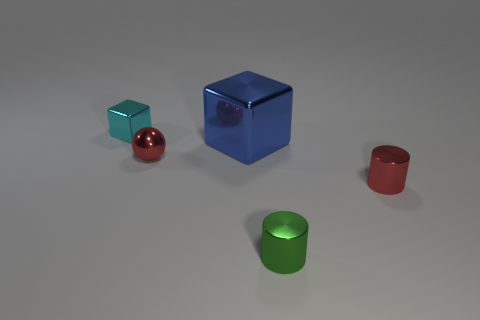There is a red shiny thing that is in front of the red metallic ball; what size is it?
Your answer should be very brief. Small. What shape is the big blue thing?
Make the answer very short. Cube. Does the shiny block behind the blue metal object have the same size as the red ball that is to the left of the red cylinder?
Keep it short and to the point. Yes. How big is the red metallic thing that is to the left of the small cylinder behind the metallic object in front of the tiny red cylinder?
Ensure brevity in your answer.  Small. What shape is the red object that is left of the metallic block in front of the shiny thing behind the big blue metal cube?
Keep it short and to the point. Sphere. What is the shape of the small thing that is in front of the tiny red cylinder?
Provide a succinct answer. Cylinder. Do the small red sphere and the small cylinder in front of the red cylinder have the same material?
Provide a short and direct response. Yes. How many other things are there of the same shape as the blue shiny object?
Your answer should be very brief. 1. Is the color of the small block the same as the shiny thing that is on the right side of the tiny green cylinder?
Provide a short and direct response. No. Is there any other thing that is the same material as the red sphere?
Make the answer very short. Yes. 